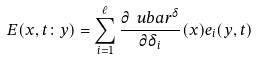<formula> <loc_0><loc_0><loc_500><loc_500>E ( x , t \colon y ) = \sum _ { i = 1 } ^ { \ell } \frac { \partial \ u b a r ^ { \delta } } { \partial \delta _ { i } } ( x ) e _ { i } ( y , t )</formula> 